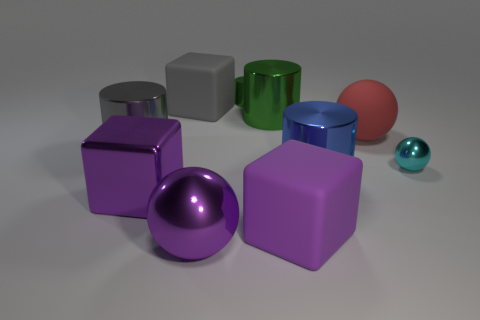Subtract all large blue cylinders. How many cylinders are left? 3 Subtract all gray cylinders. How many cylinders are left? 3 Subtract all blocks. How many objects are left? 7 Subtract 3 cylinders. How many cylinders are left? 1 Subtract all big purple metal blocks. Subtract all big purple metal balls. How many objects are left? 8 Add 6 large green metallic cylinders. How many large green metallic cylinders are left? 7 Add 3 blue things. How many blue things exist? 4 Subtract 0 cyan blocks. How many objects are left? 10 Subtract all gray cylinders. Subtract all green balls. How many cylinders are left? 3 Subtract all blue cylinders. How many green balls are left? 0 